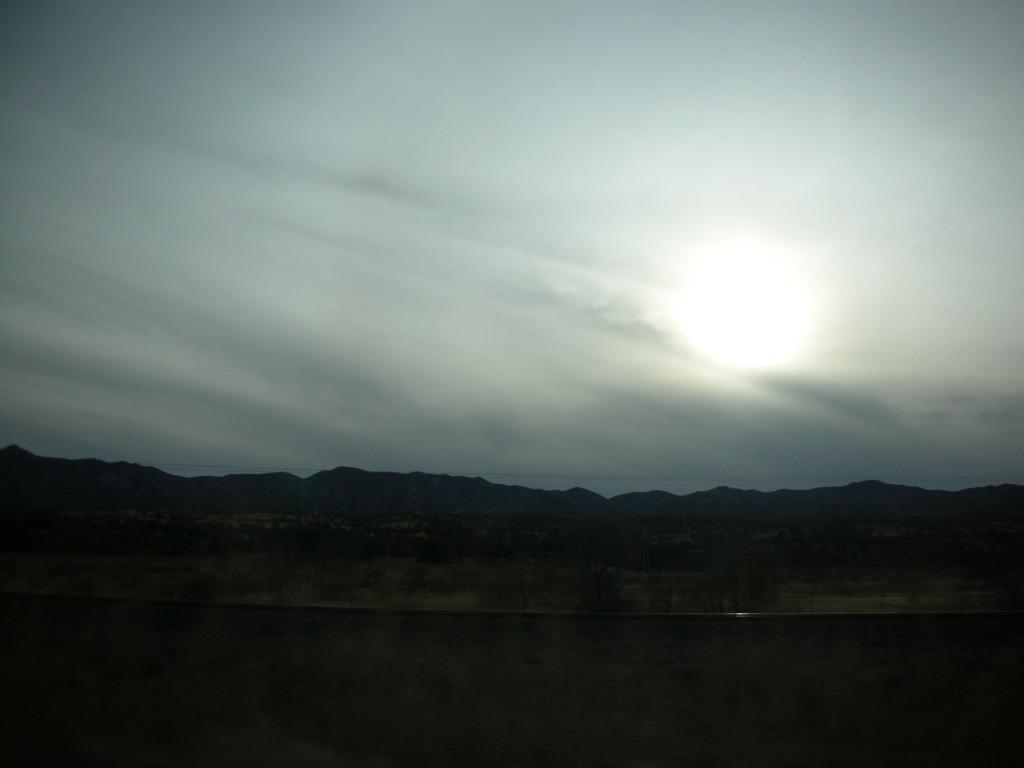Can you describe this image briefly? This picture is taken from outside of the city. In this image, we can see some mountains, rocks. At the top, we can see a sky and a moon. At the bottom, we can see black color. 